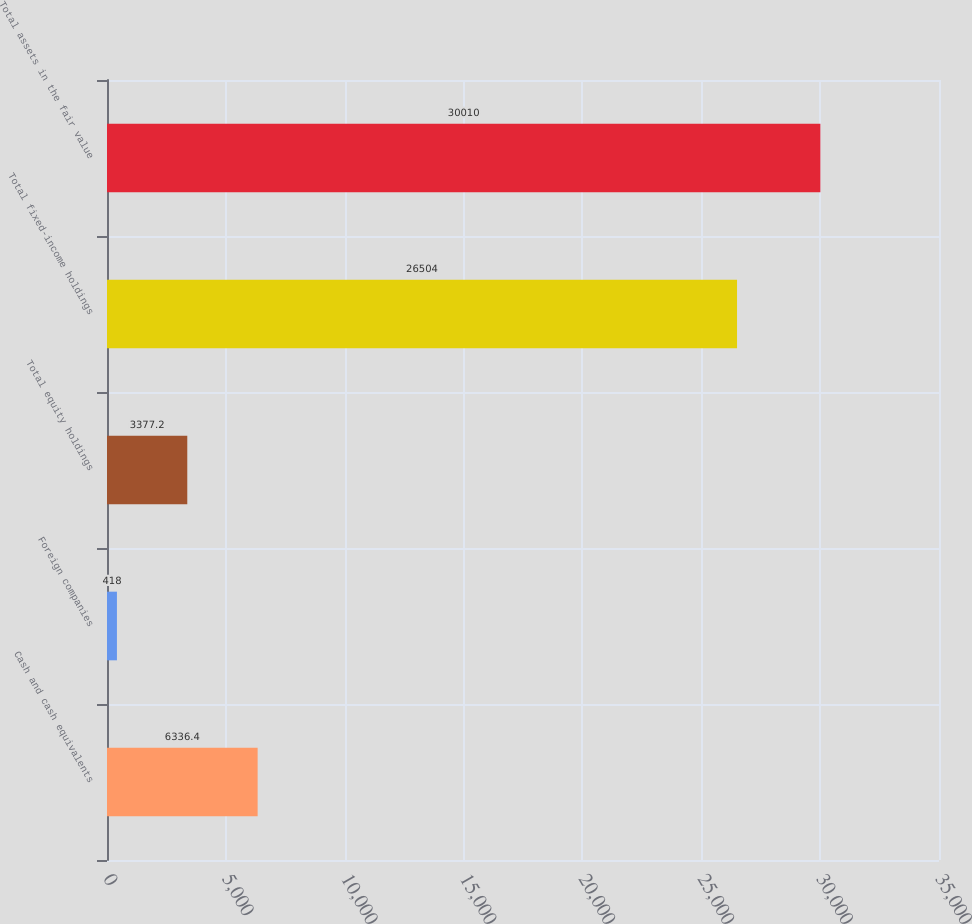<chart> <loc_0><loc_0><loc_500><loc_500><bar_chart><fcel>Cash and cash equivalents<fcel>Foreign companies<fcel>Total equity holdings<fcel>Total fixed-income holdings<fcel>Total assets in the fair value<nl><fcel>6336.4<fcel>418<fcel>3377.2<fcel>26504<fcel>30010<nl></chart> 